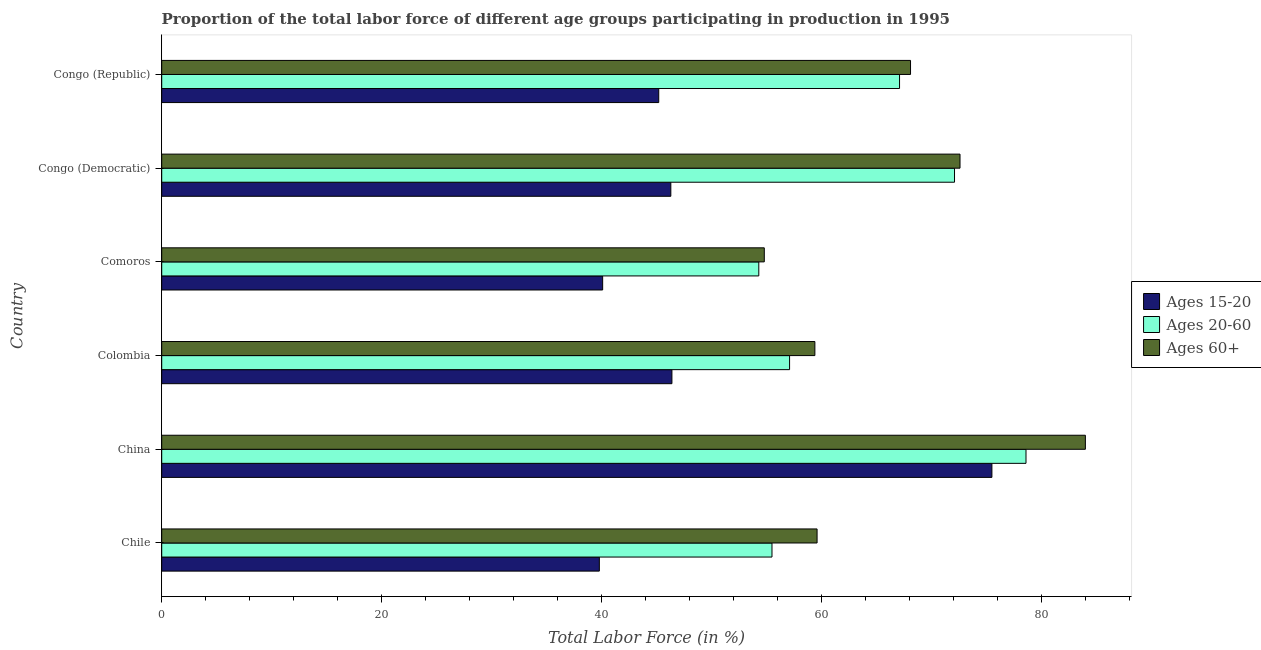How many groups of bars are there?
Give a very brief answer. 6. Are the number of bars on each tick of the Y-axis equal?
Make the answer very short. Yes. What is the label of the 1st group of bars from the top?
Offer a very short reply. Congo (Republic). What is the percentage of labor force within the age group 15-20 in Congo (Democratic)?
Your answer should be very brief. 46.3. Across all countries, what is the maximum percentage of labor force within the age group 15-20?
Ensure brevity in your answer.  75.5. Across all countries, what is the minimum percentage of labor force above age 60?
Provide a short and direct response. 54.8. What is the total percentage of labor force within the age group 20-60 in the graph?
Provide a succinct answer. 384.7. What is the difference between the percentage of labor force within the age group 15-20 in China and the percentage of labor force above age 60 in Chile?
Offer a terse response. 15.9. What is the average percentage of labor force above age 60 per country?
Provide a succinct answer. 66.42. In how many countries, is the percentage of labor force within the age group 15-20 greater than 28 %?
Give a very brief answer. 6. What is the ratio of the percentage of labor force within the age group 20-60 in Comoros to that in Congo (Republic)?
Provide a short and direct response. 0.81. What is the difference between the highest and the second highest percentage of labor force within the age group 15-20?
Provide a short and direct response. 29.1. What is the difference between the highest and the lowest percentage of labor force within the age group 15-20?
Ensure brevity in your answer.  35.7. In how many countries, is the percentage of labor force within the age group 20-60 greater than the average percentage of labor force within the age group 20-60 taken over all countries?
Make the answer very short. 3. Is the sum of the percentage of labor force above age 60 in Colombia and Congo (Republic) greater than the maximum percentage of labor force within the age group 15-20 across all countries?
Your answer should be compact. Yes. What does the 2nd bar from the top in China represents?
Make the answer very short. Ages 20-60. What does the 1st bar from the bottom in Congo (Democratic) represents?
Give a very brief answer. Ages 15-20. Is it the case that in every country, the sum of the percentage of labor force within the age group 15-20 and percentage of labor force within the age group 20-60 is greater than the percentage of labor force above age 60?
Offer a terse response. Yes. Are all the bars in the graph horizontal?
Keep it short and to the point. Yes. What is the difference between two consecutive major ticks on the X-axis?
Offer a terse response. 20. Are the values on the major ticks of X-axis written in scientific E-notation?
Provide a short and direct response. No. How many legend labels are there?
Give a very brief answer. 3. What is the title of the graph?
Provide a short and direct response. Proportion of the total labor force of different age groups participating in production in 1995. Does "Nuclear sources" appear as one of the legend labels in the graph?
Your answer should be compact. No. What is the label or title of the X-axis?
Your answer should be very brief. Total Labor Force (in %). What is the label or title of the Y-axis?
Your answer should be very brief. Country. What is the Total Labor Force (in %) in Ages 15-20 in Chile?
Your answer should be compact. 39.8. What is the Total Labor Force (in %) of Ages 20-60 in Chile?
Provide a succinct answer. 55.5. What is the Total Labor Force (in %) of Ages 60+ in Chile?
Your response must be concise. 59.6. What is the Total Labor Force (in %) in Ages 15-20 in China?
Make the answer very short. 75.5. What is the Total Labor Force (in %) in Ages 20-60 in China?
Provide a succinct answer. 78.6. What is the Total Labor Force (in %) of Ages 60+ in China?
Give a very brief answer. 84. What is the Total Labor Force (in %) of Ages 15-20 in Colombia?
Provide a short and direct response. 46.4. What is the Total Labor Force (in %) of Ages 20-60 in Colombia?
Ensure brevity in your answer.  57.1. What is the Total Labor Force (in %) in Ages 60+ in Colombia?
Offer a very short reply. 59.4. What is the Total Labor Force (in %) in Ages 15-20 in Comoros?
Offer a terse response. 40.1. What is the Total Labor Force (in %) of Ages 20-60 in Comoros?
Provide a short and direct response. 54.3. What is the Total Labor Force (in %) of Ages 60+ in Comoros?
Your answer should be compact. 54.8. What is the Total Labor Force (in %) of Ages 15-20 in Congo (Democratic)?
Make the answer very short. 46.3. What is the Total Labor Force (in %) of Ages 20-60 in Congo (Democratic)?
Your answer should be compact. 72.1. What is the Total Labor Force (in %) in Ages 60+ in Congo (Democratic)?
Ensure brevity in your answer.  72.6. What is the Total Labor Force (in %) of Ages 15-20 in Congo (Republic)?
Offer a very short reply. 45.2. What is the Total Labor Force (in %) of Ages 20-60 in Congo (Republic)?
Provide a succinct answer. 67.1. What is the Total Labor Force (in %) of Ages 60+ in Congo (Republic)?
Ensure brevity in your answer.  68.1. Across all countries, what is the maximum Total Labor Force (in %) of Ages 15-20?
Your response must be concise. 75.5. Across all countries, what is the maximum Total Labor Force (in %) in Ages 20-60?
Make the answer very short. 78.6. Across all countries, what is the minimum Total Labor Force (in %) in Ages 15-20?
Provide a succinct answer. 39.8. Across all countries, what is the minimum Total Labor Force (in %) in Ages 20-60?
Ensure brevity in your answer.  54.3. Across all countries, what is the minimum Total Labor Force (in %) in Ages 60+?
Provide a short and direct response. 54.8. What is the total Total Labor Force (in %) of Ages 15-20 in the graph?
Make the answer very short. 293.3. What is the total Total Labor Force (in %) in Ages 20-60 in the graph?
Make the answer very short. 384.7. What is the total Total Labor Force (in %) in Ages 60+ in the graph?
Keep it short and to the point. 398.5. What is the difference between the Total Labor Force (in %) of Ages 15-20 in Chile and that in China?
Your answer should be very brief. -35.7. What is the difference between the Total Labor Force (in %) in Ages 20-60 in Chile and that in China?
Your answer should be very brief. -23.1. What is the difference between the Total Labor Force (in %) in Ages 60+ in Chile and that in China?
Provide a short and direct response. -24.4. What is the difference between the Total Labor Force (in %) in Ages 15-20 in Chile and that in Colombia?
Provide a short and direct response. -6.6. What is the difference between the Total Labor Force (in %) of Ages 60+ in Chile and that in Comoros?
Provide a short and direct response. 4.8. What is the difference between the Total Labor Force (in %) in Ages 15-20 in Chile and that in Congo (Democratic)?
Make the answer very short. -6.5. What is the difference between the Total Labor Force (in %) of Ages 20-60 in Chile and that in Congo (Democratic)?
Your response must be concise. -16.6. What is the difference between the Total Labor Force (in %) of Ages 20-60 in Chile and that in Congo (Republic)?
Keep it short and to the point. -11.6. What is the difference between the Total Labor Force (in %) of Ages 15-20 in China and that in Colombia?
Your answer should be very brief. 29.1. What is the difference between the Total Labor Force (in %) in Ages 20-60 in China and that in Colombia?
Your answer should be very brief. 21.5. What is the difference between the Total Labor Force (in %) in Ages 60+ in China and that in Colombia?
Offer a very short reply. 24.6. What is the difference between the Total Labor Force (in %) of Ages 15-20 in China and that in Comoros?
Provide a short and direct response. 35.4. What is the difference between the Total Labor Force (in %) in Ages 20-60 in China and that in Comoros?
Keep it short and to the point. 24.3. What is the difference between the Total Labor Force (in %) in Ages 60+ in China and that in Comoros?
Keep it short and to the point. 29.2. What is the difference between the Total Labor Force (in %) in Ages 15-20 in China and that in Congo (Democratic)?
Your answer should be compact. 29.2. What is the difference between the Total Labor Force (in %) of Ages 15-20 in China and that in Congo (Republic)?
Your answer should be compact. 30.3. What is the difference between the Total Labor Force (in %) of Ages 60+ in China and that in Congo (Republic)?
Keep it short and to the point. 15.9. What is the difference between the Total Labor Force (in %) in Ages 15-20 in Colombia and that in Congo (Democratic)?
Give a very brief answer. 0.1. What is the difference between the Total Labor Force (in %) in Ages 20-60 in Colombia and that in Congo (Democratic)?
Provide a succinct answer. -15. What is the difference between the Total Labor Force (in %) of Ages 15-20 in Comoros and that in Congo (Democratic)?
Give a very brief answer. -6.2. What is the difference between the Total Labor Force (in %) of Ages 20-60 in Comoros and that in Congo (Democratic)?
Your answer should be compact. -17.8. What is the difference between the Total Labor Force (in %) of Ages 60+ in Comoros and that in Congo (Democratic)?
Provide a short and direct response. -17.8. What is the difference between the Total Labor Force (in %) of Ages 60+ in Congo (Democratic) and that in Congo (Republic)?
Offer a terse response. 4.5. What is the difference between the Total Labor Force (in %) of Ages 15-20 in Chile and the Total Labor Force (in %) of Ages 20-60 in China?
Give a very brief answer. -38.8. What is the difference between the Total Labor Force (in %) in Ages 15-20 in Chile and the Total Labor Force (in %) in Ages 60+ in China?
Offer a terse response. -44.2. What is the difference between the Total Labor Force (in %) in Ages 20-60 in Chile and the Total Labor Force (in %) in Ages 60+ in China?
Provide a short and direct response. -28.5. What is the difference between the Total Labor Force (in %) of Ages 15-20 in Chile and the Total Labor Force (in %) of Ages 20-60 in Colombia?
Provide a short and direct response. -17.3. What is the difference between the Total Labor Force (in %) in Ages 15-20 in Chile and the Total Labor Force (in %) in Ages 60+ in Colombia?
Offer a very short reply. -19.6. What is the difference between the Total Labor Force (in %) of Ages 20-60 in Chile and the Total Labor Force (in %) of Ages 60+ in Colombia?
Your answer should be very brief. -3.9. What is the difference between the Total Labor Force (in %) in Ages 20-60 in Chile and the Total Labor Force (in %) in Ages 60+ in Comoros?
Your answer should be very brief. 0.7. What is the difference between the Total Labor Force (in %) in Ages 15-20 in Chile and the Total Labor Force (in %) in Ages 20-60 in Congo (Democratic)?
Make the answer very short. -32.3. What is the difference between the Total Labor Force (in %) in Ages 15-20 in Chile and the Total Labor Force (in %) in Ages 60+ in Congo (Democratic)?
Offer a very short reply. -32.8. What is the difference between the Total Labor Force (in %) in Ages 20-60 in Chile and the Total Labor Force (in %) in Ages 60+ in Congo (Democratic)?
Your answer should be compact. -17.1. What is the difference between the Total Labor Force (in %) in Ages 15-20 in Chile and the Total Labor Force (in %) in Ages 20-60 in Congo (Republic)?
Ensure brevity in your answer.  -27.3. What is the difference between the Total Labor Force (in %) in Ages 15-20 in Chile and the Total Labor Force (in %) in Ages 60+ in Congo (Republic)?
Give a very brief answer. -28.3. What is the difference between the Total Labor Force (in %) of Ages 15-20 in China and the Total Labor Force (in %) of Ages 20-60 in Comoros?
Ensure brevity in your answer.  21.2. What is the difference between the Total Labor Force (in %) of Ages 15-20 in China and the Total Labor Force (in %) of Ages 60+ in Comoros?
Keep it short and to the point. 20.7. What is the difference between the Total Labor Force (in %) in Ages 20-60 in China and the Total Labor Force (in %) in Ages 60+ in Comoros?
Offer a terse response. 23.8. What is the difference between the Total Labor Force (in %) in Ages 15-20 in China and the Total Labor Force (in %) in Ages 60+ in Congo (Democratic)?
Provide a short and direct response. 2.9. What is the difference between the Total Labor Force (in %) in Ages 15-20 in China and the Total Labor Force (in %) in Ages 20-60 in Congo (Republic)?
Your answer should be very brief. 8.4. What is the difference between the Total Labor Force (in %) in Ages 15-20 in Colombia and the Total Labor Force (in %) in Ages 20-60 in Comoros?
Offer a terse response. -7.9. What is the difference between the Total Labor Force (in %) of Ages 15-20 in Colombia and the Total Labor Force (in %) of Ages 60+ in Comoros?
Your answer should be very brief. -8.4. What is the difference between the Total Labor Force (in %) in Ages 20-60 in Colombia and the Total Labor Force (in %) in Ages 60+ in Comoros?
Give a very brief answer. 2.3. What is the difference between the Total Labor Force (in %) in Ages 15-20 in Colombia and the Total Labor Force (in %) in Ages 20-60 in Congo (Democratic)?
Keep it short and to the point. -25.7. What is the difference between the Total Labor Force (in %) in Ages 15-20 in Colombia and the Total Labor Force (in %) in Ages 60+ in Congo (Democratic)?
Keep it short and to the point. -26.2. What is the difference between the Total Labor Force (in %) in Ages 20-60 in Colombia and the Total Labor Force (in %) in Ages 60+ in Congo (Democratic)?
Your answer should be compact. -15.5. What is the difference between the Total Labor Force (in %) in Ages 15-20 in Colombia and the Total Labor Force (in %) in Ages 20-60 in Congo (Republic)?
Your answer should be compact. -20.7. What is the difference between the Total Labor Force (in %) in Ages 15-20 in Colombia and the Total Labor Force (in %) in Ages 60+ in Congo (Republic)?
Provide a short and direct response. -21.7. What is the difference between the Total Labor Force (in %) of Ages 15-20 in Comoros and the Total Labor Force (in %) of Ages 20-60 in Congo (Democratic)?
Make the answer very short. -32. What is the difference between the Total Labor Force (in %) of Ages 15-20 in Comoros and the Total Labor Force (in %) of Ages 60+ in Congo (Democratic)?
Provide a short and direct response. -32.5. What is the difference between the Total Labor Force (in %) of Ages 20-60 in Comoros and the Total Labor Force (in %) of Ages 60+ in Congo (Democratic)?
Provide a succinct answer. -18.3. What is the difference between the Total Labor Force (in %) of Ages 15-20 in Congo (Democratic) and the Total Labor Force (in %) of Ages 20-60 in Congo (Republic)?
Keep it short and to the point. -20.8. What is the difference between the Total Labor Force (in %) of Ages 15-20 in Congo (Democratic) and the Total Labor Force (in %) of Ages 60+ in Congo (Republic)?
Your answer should be compact. -21.8. What is the average Total Labor Force (in %) in Ages 15-20 per country?
Keep it short and to the point. 48.88. What is the average Total Labor Force (in %) in Ages 20-60 per country?
Keep it short and to the point. 64.12. What is the average Total Labor Force (in %) in Ages 60+ per country?
Your answer should be compact. 66.42. What is the difference between the Total Labor Force (in %) of Ages 15-20 and Total Labor Force (in %) of Ages 20-60 in Chile?
Ensure brevity in your answer.  -15.7. What is the difference between the Total Labor Force (in %) in Ages 15-20 and Total Labor Force (in %) in Ages 60+ in Chile?
Your response must be concise. -19.8. What is the difference between the Total Labor Force (in %) of Ages 20-60 and Total Labor Force (in %) of Ages 60+ in Chile?
Your answer should be very brief. -4.1. What is the difference between the Total Labor Force (in %) in Ages 15-20 and Total Labor Force (in %) in Ages 60+ in China?
Your answer should be compact. -8.5. What is the difference between the Total Labor Force (in %) of Ages 20-60 and Total Labor Force (in %) of Ages 60+ in China?
Provide a succinct answer. -5.4. What is the difference between the Total Labor Force (in %) in Ages 15-20 and Total Labor Force (in %) in Ages 20-60 in Colombia?
Your response must be concise. -10.7. What is the difference between the Total Labor Force (in %) of Ages 15-20 and Total Labor Force (in %) of Ages 60+ in Colombia?
Your response must be concise. -13. What is the difference between the Total Labor Force (in %) of Ages 20-60 and Total Labor Force (in %) of Ages 60+ in Colombia?
Provide a succinct answer. -2.3. What is the difference between the Total Labor Force (in %) in Ages 15-20 and Total Labor Force (in %) in Ages 60+ in Comoros?
Your response must be concise. -14.7. What is the difference between the Total Labor Force (in %) in Ages 15-20 and Total Labor Force (in %) in Ages 20-60 in Congo (Democratic)?
Give a very brief answer. -25.8. What is the difference between the Total Labor Force (in %) of Ages 15-20 and Total Labor Force (in %) of Ages 60+ in Congo (Democratic)?
Ensure brevity in your answer.  -26.3. What is the difference between the Total Labor Force (in %) of Ages 15-20 and Total Labor Force (in %) of Ages 20-60 in Congo (Republic)?
Keep it short and to the point. -21.9. What is the difference between the Total Labor Force (in %) of Ages 15-20 and Total Labor Force (in %) of Ages 60+ in Congo (Republic)?
Offer a terse response. -22.9. What is the difference between the Total Labor Force (in %) of Ages 20-60 and Total Labor Force (in %) of Ages 60+ in Congo (Republic)?
Make the answer very short. -1. What is the ratio of the Total Labor Force (in %) in Ages 15-20 in Chile to that in China?
Ensure brevity in your answer.  0.53. What is the ratio of the Total Labor Force (in %) of Ages 20-60 in Chile to that in China?
Make the answer very short. 0.71. What is the ratio of the Total Labor Force (in %) of Ages 60+ in Chile to that in China?
Provide a succinct answer. 0.71. What is the ratio of the Total Labor Force (in %) of Ages 15-20 in Chile to that in Colombia?
Your response must be concise. 0.86. What is the ratio of the Total Labor Force (in %) of Ages 20-60 in Chile to that in Colombia?
Your answer should be compact. 0.97. What is the ratio of the Total Labor Force (in %) of Ages 15-20 in Chile to that in Comoros?
Your answer should be very brief. 0.99. What is the ratio of the Total Labor Force (in %) of Ages 20-60 in Chile to that in Comoros?
Provide a succinct answer. 1.02. What is the ratio of the Total Labor Force (in %) in Ages 60+ in Chile to that in Comoros?
Your response must be concise. 1.09. What is the ratio of the Total Labor Force (in %) of Ages 15-20 in Chile to that in Congo (Democratic)?
Provide a succinct answer. 0.86. What is the ratio of the Total Labor Force (in %) in Ages 20-60 in Chile to that in Congo (Democratic)?
Give a very brief answer. 0.77. What is the ratio of the Total Labor Force (in %) in Ages 60+ in Chile to that in Congo (Democratic)?
Keep it short and to the point. 0.82. What is the ratio of the Total Labor Force (in %) of Ages 15-20 in Chile to that in Congo (Republic)?
Provide a succinct answer. 0.88. What is the ratio of the Total Labor Force (in %) of Ages 20-60 in Chile to that in Congo (Republic)?
Provide a succinct answer. 0.83. What is the ratio of the Total Labor Force (in %) in Ages 60+ in Chile to that in Congo (Republic)?
Offer a very short reply. 0.88. What is the ratio of the Total Labor Force (in %) in Ages 15-20 in China to that in Colombia?
Offer a very short reply. 1.63. What is the ratio of the Total Labor Force (in %) of Ages 20-60 in China to that in Colombia?
Offer a very short reply. 1.38. What is the ratio of the Total Labor Force (in %) in Ages 60+ in China to that in Colombia?
Your answer should be compact. 1.41. What is the ratio of the Total Labor Force (in %) of Ages 15-20 in China to that in Comoros?
Provide a succinct answer. 1.88. What is the ratio of the Total Labor Force (in %) in Ages 20-60 in China to that in Comoros?
Make the answer very short. 1.45. What is the ratio of the Total Labor Force (in %) in Ages 60+ in China to that in Comoros?
Ensure brevity in your answer.  1.53. What is the ratio of the Total Labor Force (in %) of Ages 15-20 in China to that in Congo (Democratic)?
Provide a short and direct response. 1.63. What is the ratio of the Total Labor Force (in %) in Ages 20-60 in China to that in Congo (Democratic)?
Make the answer very short. 1.09. What is the ratio of the Total Labor Force (in %) in Ages 60+ in China to that in Congo (Democratic)?
Make the answer very short. 1.16. What is the ratio of the Total Labor Force (in %) in Ages 15-20 in China to that in Congo (Republic)?
Your answer should be very brief. 1.67. What is the ratio of the Total Labor Force (in %) of Ages 20-60 in China to that in Congo (Republic)?
Offer a terse response. 1.17. What is the ratio of the Total Labor Force (in %) in Ages 60+ in China to that in Congo (Republic)?
Keep it short and to the point. 1.23. What is the ratio of the Total Labor Force (in %) in Ages 15-20 in Colombia to that in Comoros?
Make the answer very short. 1.16. What is the ratio of the Total Labor Force (in %) in Ages 20-60 in Colombia to that in Comoros?
Make the answer very short. 1.05. What is the ratio of the Total Labor Force (in %) of Ages 60+ in Colombia to that in Comoros?
Give a very brief answer. 1.08. What is the ratio of the Total Labor Force (in %) in Ages 15-20 in Colombia to that in Congo (Democratic)?
Make the answer very short. 1. What is the ratio of the Total Labor Force (in %) in Ages 20-60 in Colombia to that in Congo (Democratic)?
Your answer should be compact. 0.79. What is the ratio of the Total Labor Force (in %) in Ages 60+ in Colombia to that in Congo (Democratic)?
Provide a short and direct response. 0.82. What is the ratio of the Total Labor Force (in %) of Ages 15-20 in Colombia to that in Congo (Republic)?
Provide a short and direct response. 1.03. What is the ratio of the Total Labor Force (in %) in Ages 20-60 in Colombia to that in Congo (Republic)?
Offer a very short reply. 0.85. What is the ratio of the Total Labor Force (in %) in Ages 60+ in Colombia to that in Congo (Republic)?
Provide a succinct answer. 0.87. What is the ratio of the Total Labor Force (in %) in Ages 15-20 in Comoros to that in Congo (Democratic)?
Provide a short and direct response. 0.87. What is the ratio of the Total Labor Force (in %) in Ages 20-60 in Comoros to that in Congo (Democratic)?
Provide a short and direct response. 0.75. What is the ratio of the Total Labor Force (in %) of Ages 60+ in Comoros to that in Congo (Democratic)?
Make the answer very short. 0.75. What is the ratio of the Total Labor Force (in %) of Ages 15-20 in Comoros to that in Congo (Republic)?
Provide a short and direct response. 0.89. What is the ratio of the Total Labor Force (in %) in Ages 20-60 in Comoros to that in Congo (Republic)?
Your response must be concise. 0.81. What is the ratio of the Total Labor Force (in %) in Ages 60+ in Comoros to that in Congo (Republic)?
Your answer should be compact. 0.8. What is the ratio of the Total Labor Force (in %) of Ages 15-20 in Congo (Democratic) to that in Congo (Republic)?
Provide a succinct answer. 1.02. What is the ratio of the Total Labor Force (in %) in Ages 20-60 in Congo (Democratic) to that in Congo (Republic)?
Your answer should be compact. 1.07. What is the ratio of the Total Labor Force (in %) in Ages 60+ in Congo (Democratic) to that in Congo (Republic)?
Ensure brevity in your answer.  1.07. What is the difference between the highest and the second highest Total Labor Force (in %) of Ages 15-20?
Provide a short and direct response. 29.1. What is the difference between the highest and the lowest Total Labor Force (in %) of Ages 15-20?
Provide a succinct answer. 35.7. What is the difference between the highest and the lowest Total Labor Force (in %) of Ages 20-60?
Your response must be concise. 24.3. What is the difference between the highest and the lowest Total Labor Force (in %) of Ages 60+?
Offer a terse response. 29.2. 